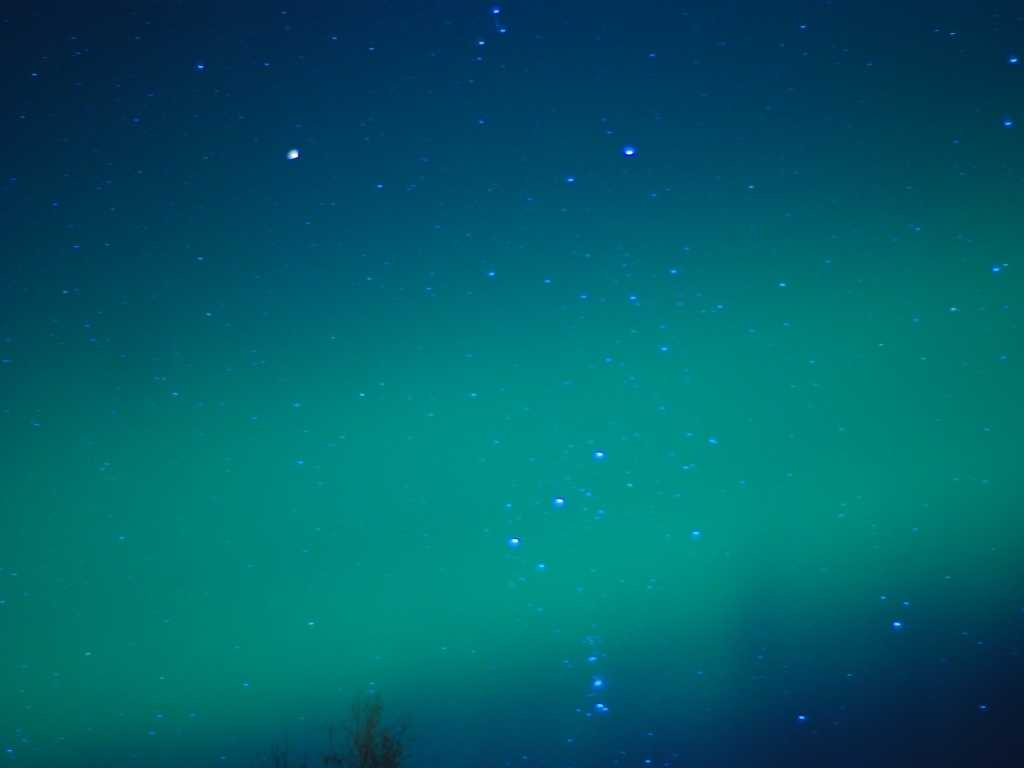What's the best time to observe the phenomenon shown in this image? The best time to witness the Northern Lights is during the winter months when the nights are longer and darker, providing a perfect backdrop for the lights to make their magical appearance, usually peaking between 9 PM and 2 AM local time. 